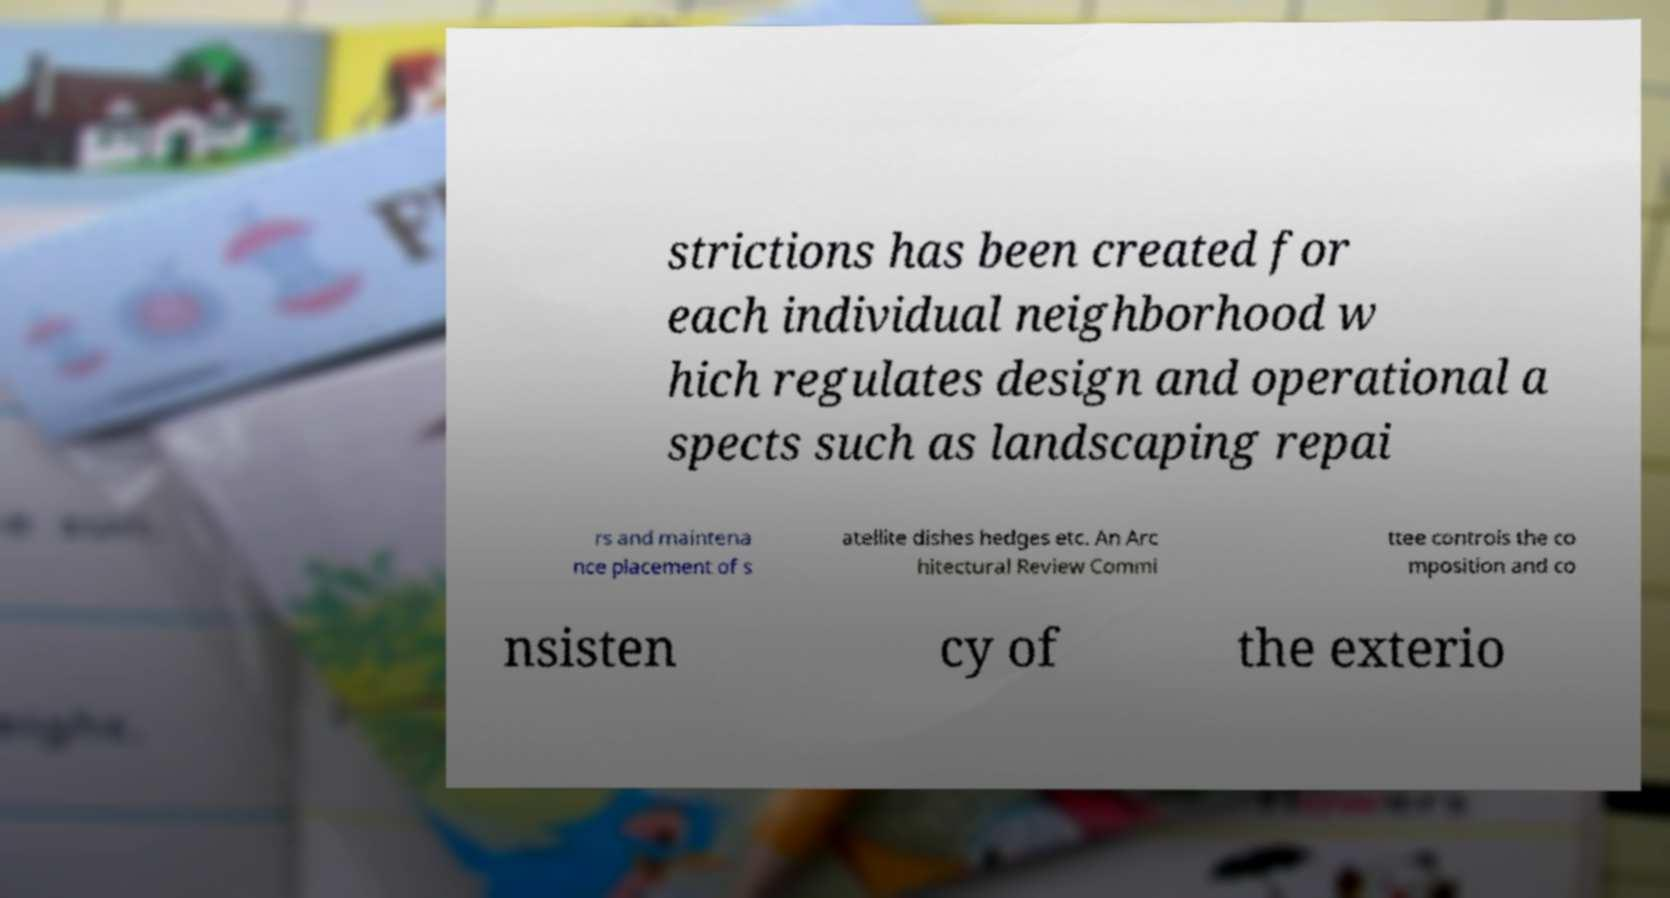Can you accurately transcribe the text from the provided image for me? strictions has been created for each individual neighborhood w hich regulates design and operational a spects such as landscaping repai rs and maintena nce placement of s atellite dishes hedges etc. An Arc hitectural Review Commi ttee controls the co mposition and co nsisten cy of the exterio 